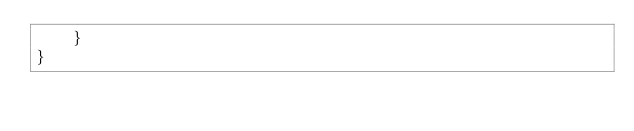<code> <loc_0><loc_0><loc_500><loc_500><_Java_>    }
}
</code> 